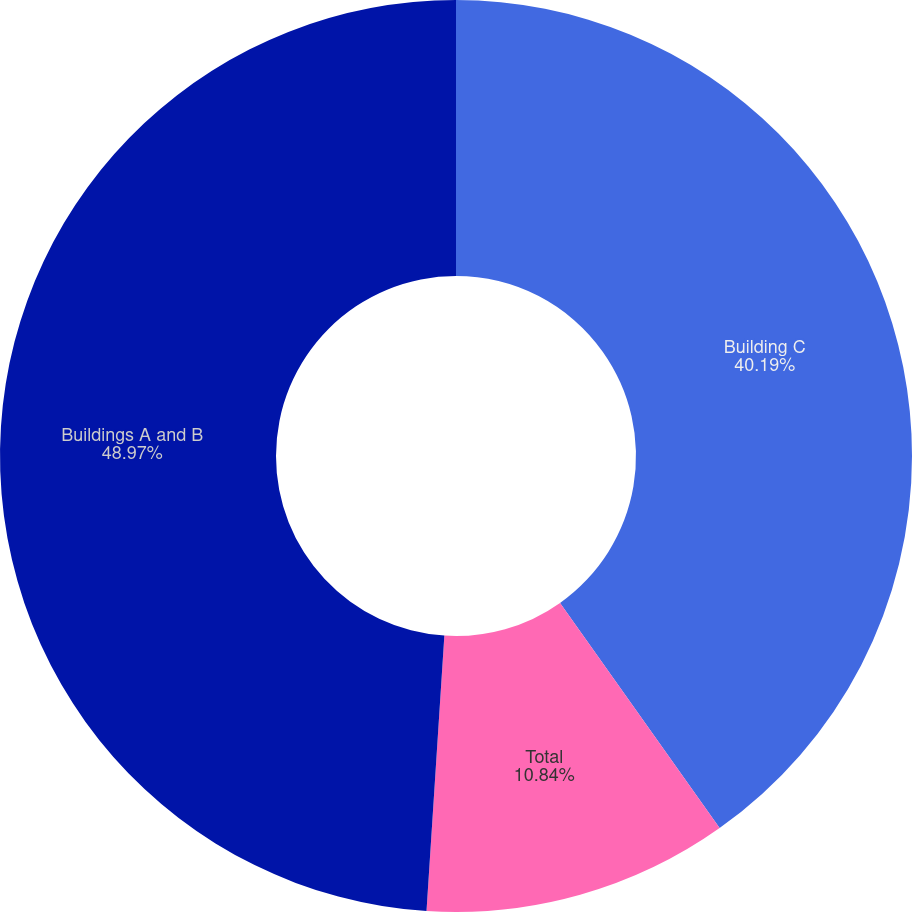Convert chart. <chart><loc_0><loc_0><loc_500><loc_500><pie_chart><fcel>Building C<fcel>Total<fcel>Buildings A and B<nl><fcel>40.19%<fcel>10.84%<fcel>48.97%<nl></chart> 